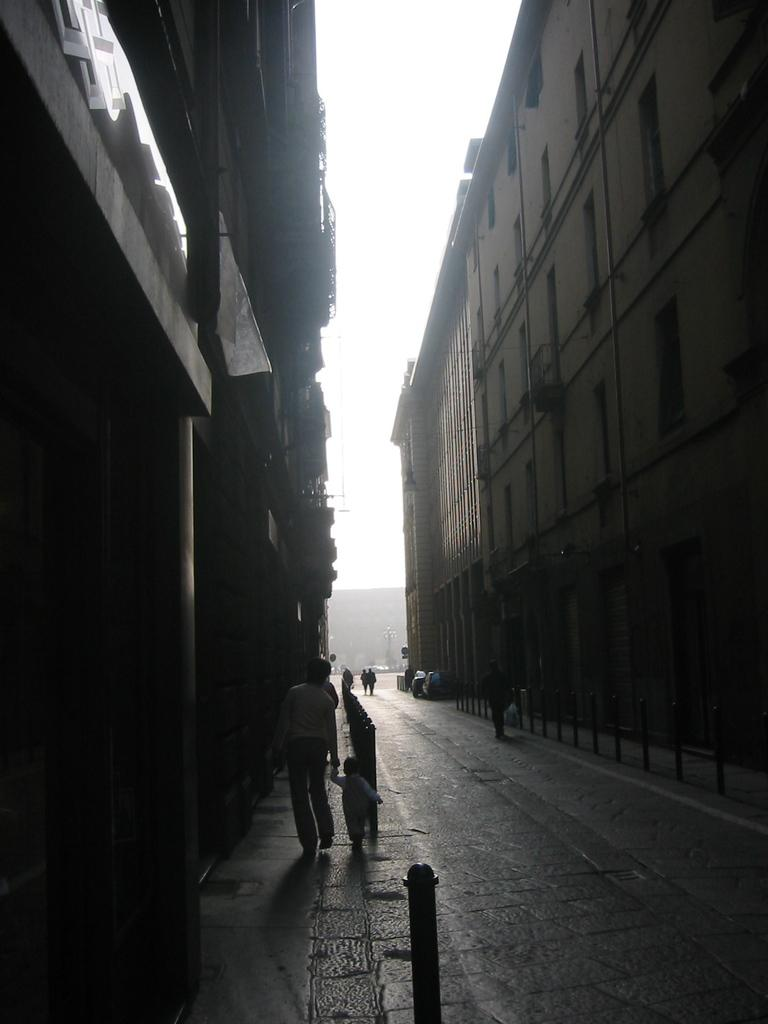What are the people in the image doing? The people in the image are walking on the road. What structures can be seen in the image? There are buildings in the image. What object is in front of the buildings? There is a metal rod in front of the buildings. What can be seen in the distance in the image? The sky is visible in the background of the image. What type of popcorn is being sold on the street in the image? There is no popcorn present in the image; it features people walking on the road and buildings with a metal rod in front. 